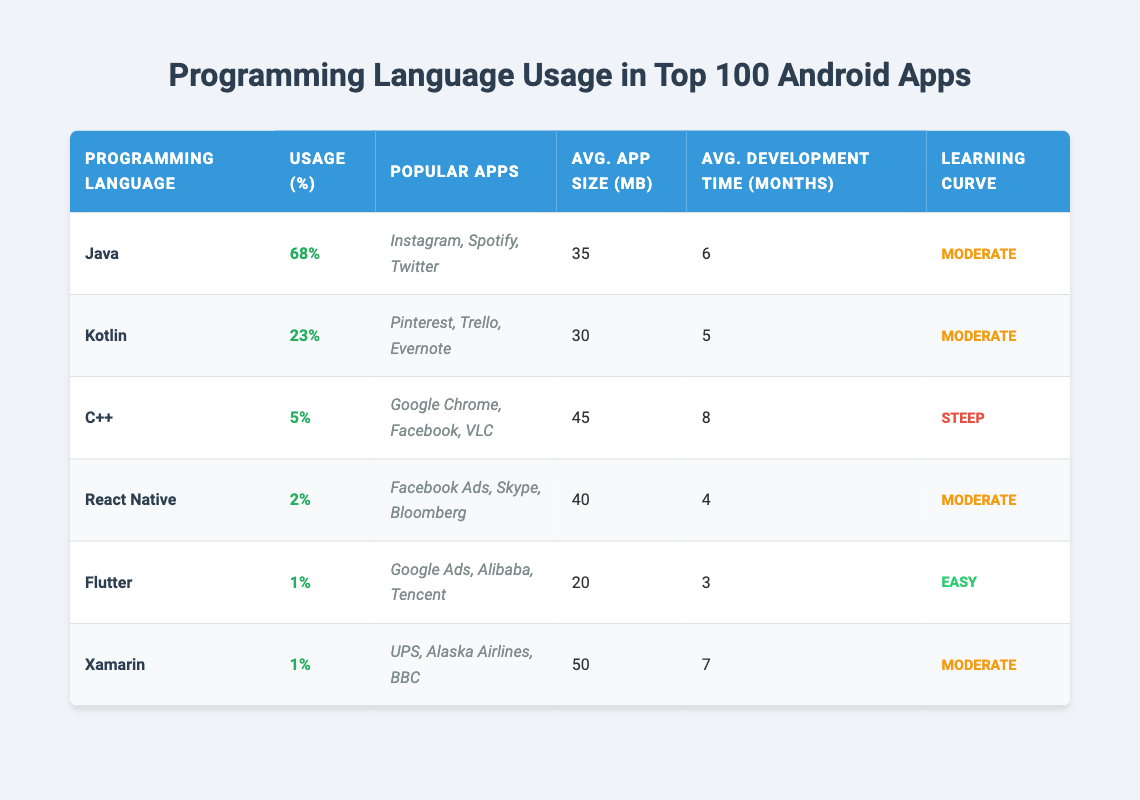What is the most used programming language in the top 100 Android apps? According to the table, Java has the highest usage percentage at 68%.
Answer: Java Which programming language has the lowest usage percentage? Flutter and Xamarin both have a usage percentage of 1%, which is the lowest among the listed languages.
Answer: Flutter and Xamarin What is the average app size for Kotlin? The average app size for Kotlin, as stated in the table, is 30 MB.
Answer: 30 MB Which languages have a moderate learning curve? Both Java and Kotlin have a moderate learning curve, according to the descriptions in the table.
Answer: Java and Kotlin How many months does it take on average to develop an app using C++? The average development time for C++ is 8 months, as indicated in the table.
Answer: 8 months Which programming language has the highest average app size? C++ has the highest average app size at 45 MB.
Answer: 45 MB Is it true that React Native has a shorter average development time than Kotlin? Yes, React Native has an average development time of 4 months, while Kotlin has 5 months, making React Native faster in terms of development.
Answer: Yes If you combine the usage percentages of Flutter and Xamarin, what do you get? Adding the usage percentages of Flutter (1%) and Xamarin (1%) gives a total of 2%.
Answer: 2% Which programming language takes the least amount of time to learn, according to the table? Flutter is indicated as having an easy learning curve, which suggests it takes the least amount of time to learn.
Answer: Flutter 